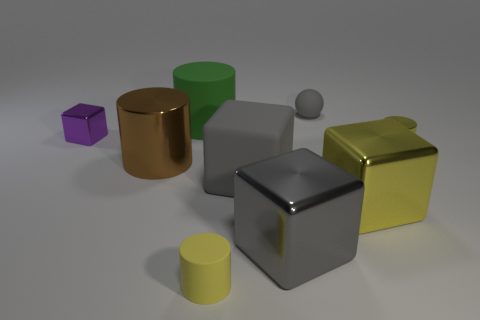Do the matte sphere and the big rubber cube have the same color?
Keep it short and to the point. Yes. The green cylinder in front of the object that is behind the green thing is made of what material?
Make the answer very short. Rubber. How many things are either big blue matte cylinders or small shiny things that are to the left of the big green matte object?
Keep it short and to the point. 1. What is the size of the gray cube that is the same material as the brown cylinder?
Your answer should be compact. Large. Is the number of objects to the left of the green cylinder greater than the number of tiny gray rubber things?
Make the answer very short. Yes. What size is the cube that is both left of the gray shiny thing and in front of the brown cylinder?
Offer a terse response. Large. What material is the big yellow object that is the same shape as the small purple metallic object?
Your answer should be very brief. Metal. There is a gray metallic thing that is in front of the brown shiny object; is its size the same as the small purple metallic thing?
Provide a succinct answer. No. There is a rubber object that is both behind the large yellow shiny block and in front of the large green cylinder; what color is it?
Your response must be concise. Gray. How many metal things are on the left side of the tiny matte object in front of the tiny yellow shiny cylinder?
Offer a very short reply. 2. 